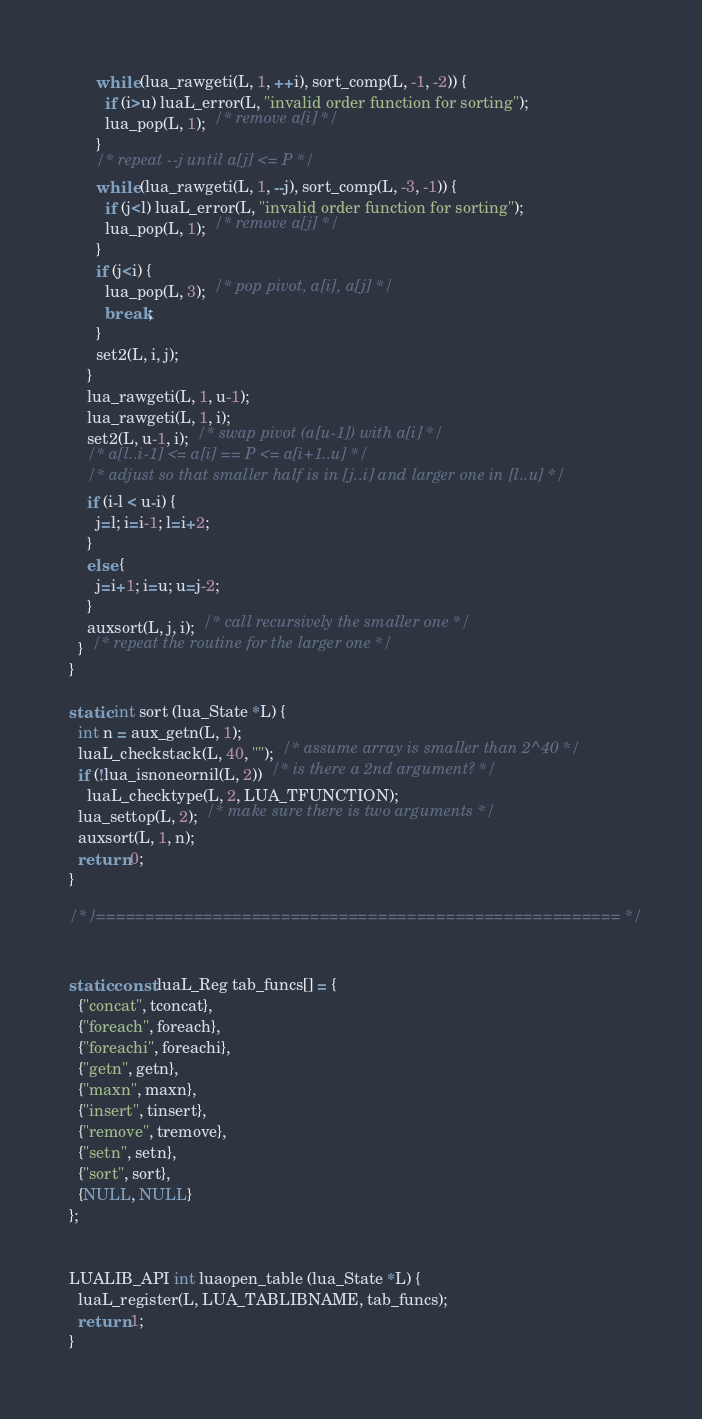Convert code to text. <code><loc_0><loc_0><loc_500><loc_500><_C_>      while (lua_rawgeti(L, 1, ++i), sort_comp(L, -1, -2)) {
        if (i>u) luaL_error(L, "invalid order function for sorting");
        lua_pop(L, 1);  /* remove a[i] */
      }
      /* repeat --j until a[j] <= P */
      while (lua_rawgeti(L, 1, --j), sort_comp(L, -3, -1)) {
        if (j<l) luaL_error(L, "invalid order function for sorting");
        lua_pop(L, 1);  /* remove a[j] */
      }
      if (j<i) {
        lua_pop(L, 3);  /* pop pivot, a[i], a[j] */
        break;
      }
      set2(L, i, j);
    }
    lua_rawgeti(L, 1, u-1);
    lua_rawgeti(L, 1, i);
    set2(L, u-1, i);  /* swap pivot (a[u-1]) with a[i] */
    /* a[l..i-1] <= a[i] == P <= a[i+1..u] */
    /* adjust so that smaller half is in [j..i] and larger one in [l..u] */
    if (i-l < u-i) {
      j=l; i=i-1; l=i+2;
    }
    else {
      j=i+1; i=u; u=j-2;
    }
    auxsort(L, j, i);  /* call recursively the smaller one */
  }  /* repeat the routine for the larger one */
}

static int sort (lua_State *L) {
  int n = aux_getn(L, 1);
  luaL_checkstack(L, 40, "");  /* assume array is smaller than 2^40 */
  if (!lua_isnoneornil(L, 2))  /* is there a 2nd argument? */
    luaL_checktype(L, 2, LUA_TFUNCTION);
  lua_settop(L, 2);  /* make sure there is two arguments */
  auxsort(L, 1, n);
  return 0;
}

/* }====================================================== */


static const luaL_Reg tab_funcs[] = {
  {"concat", tconcat},
  {"foreach", foreach},
  {"foreachi", foreachi},
  {"getn", getn},
  {"maxn", maxn},
  {"insert", tinsert},
  {"remove", tremove},
  {"setn", setn},
  {"sort", sort},
  {NULL, NULL}
};


LUALIB_API int luaopen_table (lua_State *L) {
  luaL_register(L, LUA_TABLIBNAME, tab_funcs);
  return 1;
}

</code> 